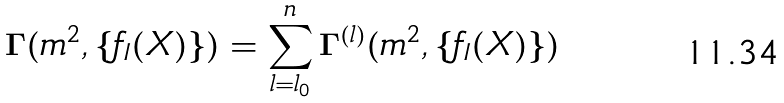<formula> <loc_0><loc_0><loc_500><loc_500>\Gamma ( m ^ { 2 } , \{ f _ { I } ( X ) \} ) = \sum _ { l = l _ { 0 } } ^ { n } \Gamma ^ { ( l ) } ( m ^ { 2 } , \{ f _ { I } ( X ) \} )</formula> 